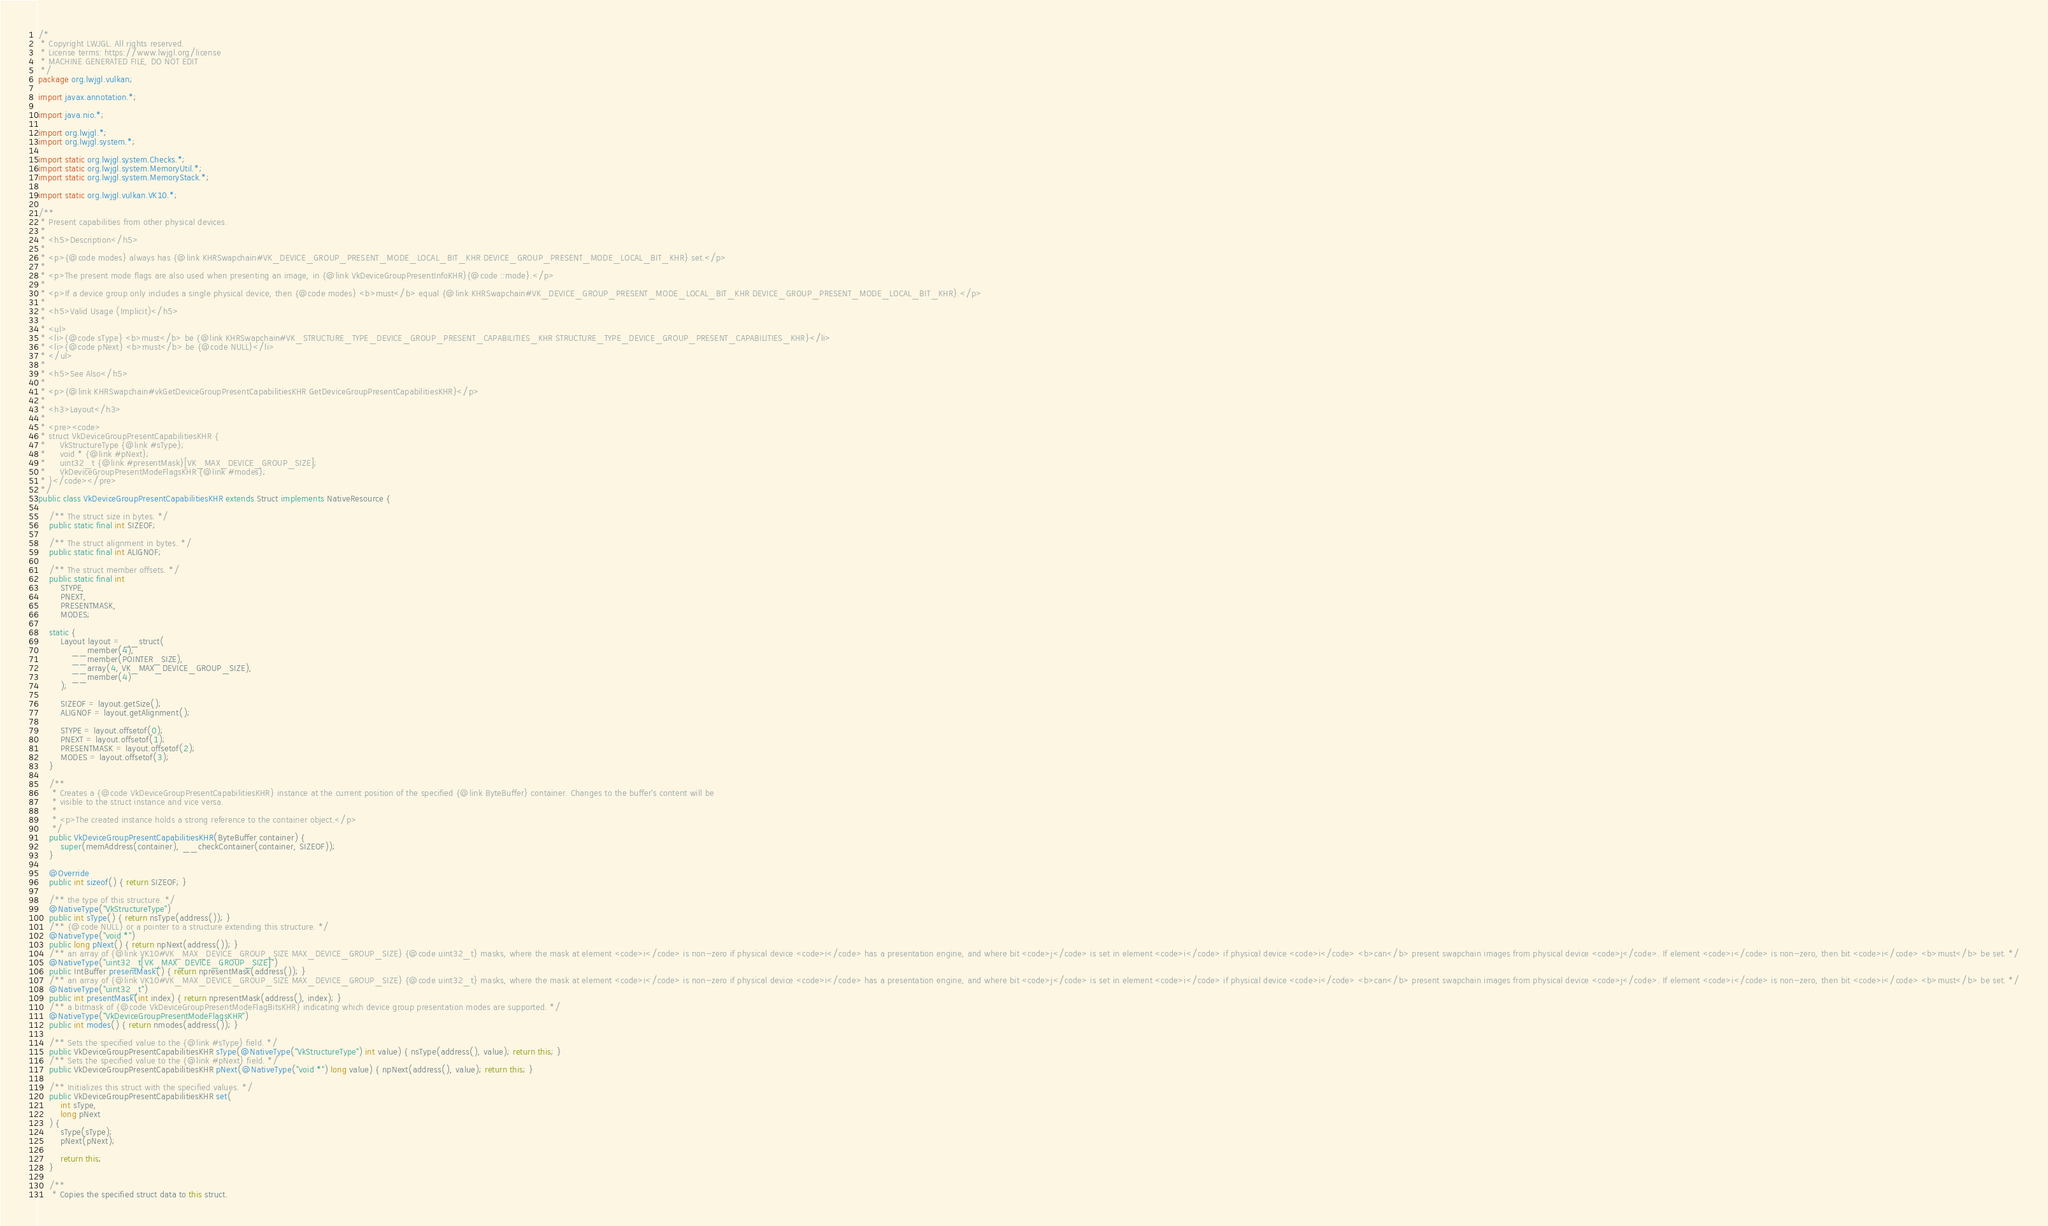Convert code to text. <code><loc_0><loc_0><loc_500><loc_500><_Java_>/*
 * Copyright LWJGL. All rights reserved.
 * License terms: https://www.lwjgl.org/license
 * MACHINE GENERATED FILE, DO NOT EDIT
 */
package org.lwjgl.vulkan;

import javax.annotation.*;

import java.nio.*;

import org.lwjgl.*;
import org.lwjgl.system.*;

import static org.lwjgl.system.Checks.*;
import static org.lwjgl.system.MemoryUtil.*;
import static org.lwjgl.system.MemoryStack.*;

import static org.lwjgl.vulkan.VK10.*;

/**
 * Present capabilities from other physical devices.
 * 
 * <h5>Description</h5>
 * 
 * <p>{@code modes} always has {@link KHRSwapchain#VK_DEVICE_GROUP_PRESENT_MODE_LOCAL_BIT_KHR DEVICE_GROUP_PRESENT_MODE_LOCAL_BIT_KHR} set.</p>
 * 
 * <p>The present mode flags are also used when presenting an image, in {@link VkDeviceGroupPresentInfoKHR}{@code ::mode}.</p>
 * 
 * <p>If a device group only includes a single physical device, then {@code modes} <b>must</b> equal {@link KHRSwapchain#VK_DEVICE_GROUP_PRESENT_MODE_LOCAL_BIT_KHR DEVICE_GROUP_PRESENT_MODE_LOCAL_BIT_KHR}.</p>
 * 
 * <h5>Valid Usage (Implicit)</h5>
 * 
 * <ul>
 * <li>{@code sType} <b>must</b> be {@link KHRSwapchain#VK_STRUCTURE_TYPE_DEVICE_GROUP_PRESENT_CAPABILITIES_KHR STRUCTURE_TYPE_DEVICE_GROUP_PRESENT_CAPABILITIES_KHR}</li>
 * <li>{@code pNext} <b>must</b> be {@code NULL}</li>
 * </ul>
 * 
 * <h5>See Also</h5>
 * 
 * <p>{@link KHRSwapchain#vkGetDeviceGroupPresentCapabilitiesKHR GetDeviceGroupPresentCapabilitiesKHR}</p>
 * 
 * <h3>Layout</h3>
 * 
 * <pre><code>
 * struct VkDeviceGroupPresentCapabilitiesKHR {
 *     VkStructureType {@link #sType};
 *     void * {@link #pNext};
 *     uint32_t {@link #presentMask}[VK_MAX_DEVICE_GROUP_SIZE];
 *     VkDeviceGroupPresentModeFlagsKHR {@link #modes};
 * }</code></pre>
 */
public class VkDeviceGroupPresentCapabilitiesKHR extends Struct implements NativeResource {

    /** The struct size in bytes. */
    public static final int SIZEOF;

    /** The struct alignment in bytes. */
    public static final int ALIGNOF;

    /** The struct member offsets. */
    public static final int
        STYPE,
        PNEXT,
        PRESENTMASK,
        MODES;

    static {
        Layout layout = __struct(
            __member(4),
            __member(POINTER_SIZE),
            __array(4, VK_MAX_DEVICE_GROUP_SIZE),
            __member(4)
        );

        SIZEOF = layout.getSize();
        ALIGNOF = layout.getAlignment();

        STYPE = layout.offsetof(0);
        PNEXT = layout.offsetof(1);
        PRESENTMASK = layout.offsetof(2);
        MODES = layout.offsetof(3);
    }

    /**
     * Creates a {@code VkDeviceGroupPresentCapabilitiesKHR} instance at the current position of the specified {@link ByteBuffer} container. Changes to the buffer's content will be
     * visible to the struct instance and vice versa.
     *
     * <p>The created instance holds a strong reference to the container object.</p>
     */
    public VkDeviceGroupPresentCapabilitiesKHR(ByteBuffer container) {
        super(memAddress(container), __checkContainer(container, SIZEOF));
    }

    @Override
    public int sizeof() { return SIZEOF; }

    /** the type of this structure. */
    @NativeType("VkStructureType")
    public int sType() { return nsType(address()); }
    /** {@code NULL} or a pointer to a structure extending this structure. */
    @NativeType("void *")
    public long pNext() { return npNext(address()); }
    /** an array of {@link VK10#VK_MAX_DEVICE_GROUP_SIZE MAX_DEVICE_GROUP_SIZE} {@code uint32_t} masks, where the mask at element <code>i</code> is non-zero if physical device <code>i</code> has a presentation engine, and where bit <code>j</code> is set in element <code>i</code> if physical device <code>i</code> <b>can</b> present swapchain images from physical device <code>j</code>. If element <code>i</code> is non-zero, then bit <code>i</code> <b>must</b> be set. */
    @NativeType("uint32_t[VK_MAX_DEVICE_GROUP_SIZE]")
    public IntBuffer presentMask() { return npresentMask(address()); }
    /** an array of {@link VK10#VK_MAX_DEVICE_GROUP_SIZE MAX_DEVICE_GROUP_SIZE} {@code uint32_t} masks, where the mask at element <code>i</code> is non-zero if physical device <code>i</code> has a presentation engine, and where bit <code>j</code> is set in element <code>i</code> if physical device <code>i</code> <b>can</b> present swapchain images from physical device <code>j</code>. If element <code>i</code> is non-zero, then bit <code>i</code> <b>must</b> be set. */
    @NativeType("uint32_t")
    public int presentMask(int index) { return npresentMask(address(), index); }
    /** a bitmask of {@code VkDeviceGroupPresentModeFlagBitsKHR} indicating which device group presentation modes are supported. */
    @NativeType("VkDeviceGroupPresentModeFlagsKHR")
    public int modes() { return nmodes(address()); }

    /** Sets the specified value to the {@link #sType} field. */
    public VkDeviceGroupPresentCapabilitiesKHR sType(@NativeType("VkStructureType") int value) { nsType(address(), value); return this; }
    /** Sets the specified value to the {@link #pNext} field. */
    public VkDeviceGroupPresentCapabilitiesKHR pNext(@NativeType("void *") long value) { npNext(address(), value); return this; }

    /** Initializes this struct with the specified values. */
    public VkDeviceGroupPresentCapabilitiesKHR set(
        int sType,
        long pNext
    ) {
        sType(sType);
        pNext(pNext);

        return this;
    }

    /**
     * Copies the specified struct data to this struct.</code> 